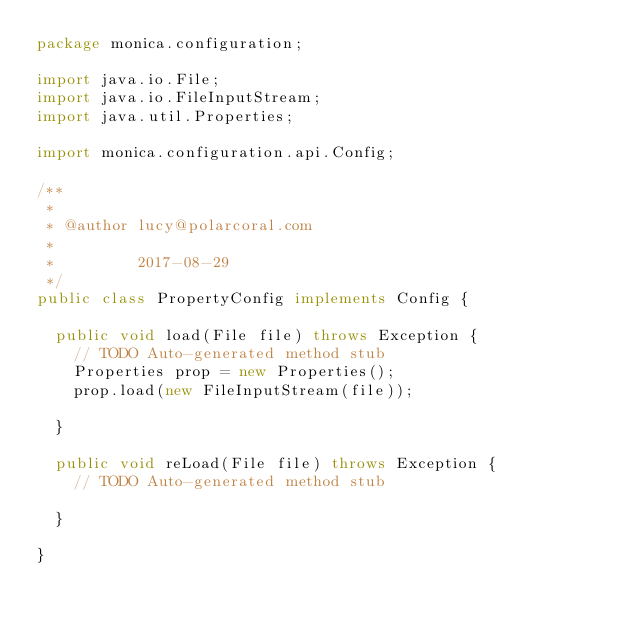Convert code to text. <code><loc_0><loc_0><loc_500><loc_500><_Java_>package monica.configuration;

import java.io.File;
import java.io.FileInputStream;
import java.util.Properties;

import monica.configuration.api.Config;

/**
 * 
 * @author lucy@polarcoral.com
 *
 *         2017-08-29
 */
public class PropertyConfig implements Config {

	public void load(File file) throws Exception {
		// TODO Auto-generated method stub
		Properties prop = new Properties();
		prop.load(new FileInputStream(file));

	}

	public void reLoad(File file) throws Exception {
		// TODO Auto-generated method stub

	}

}
</code> 